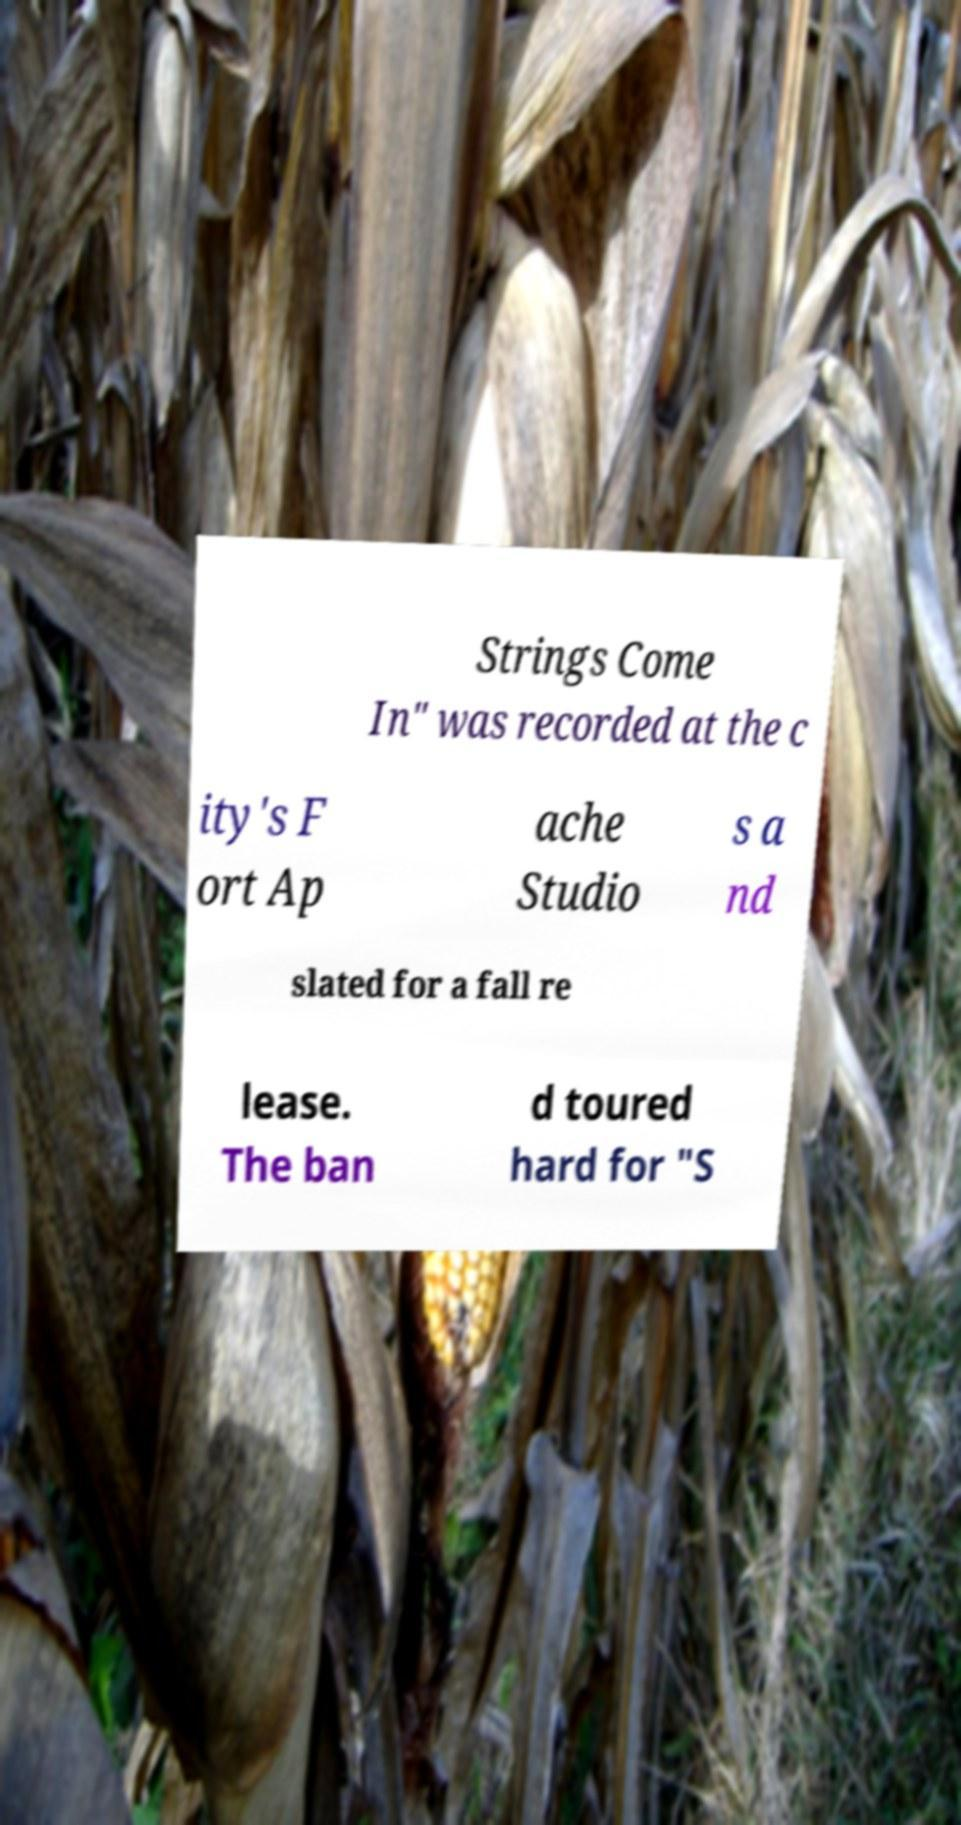Can you accurately transcribe the text from the provided image for me? Strings Come In" was recorded at the c ity's F ort Ap ache Studio s a nd slated for a fall re lease. The ban d toured hard for "S 